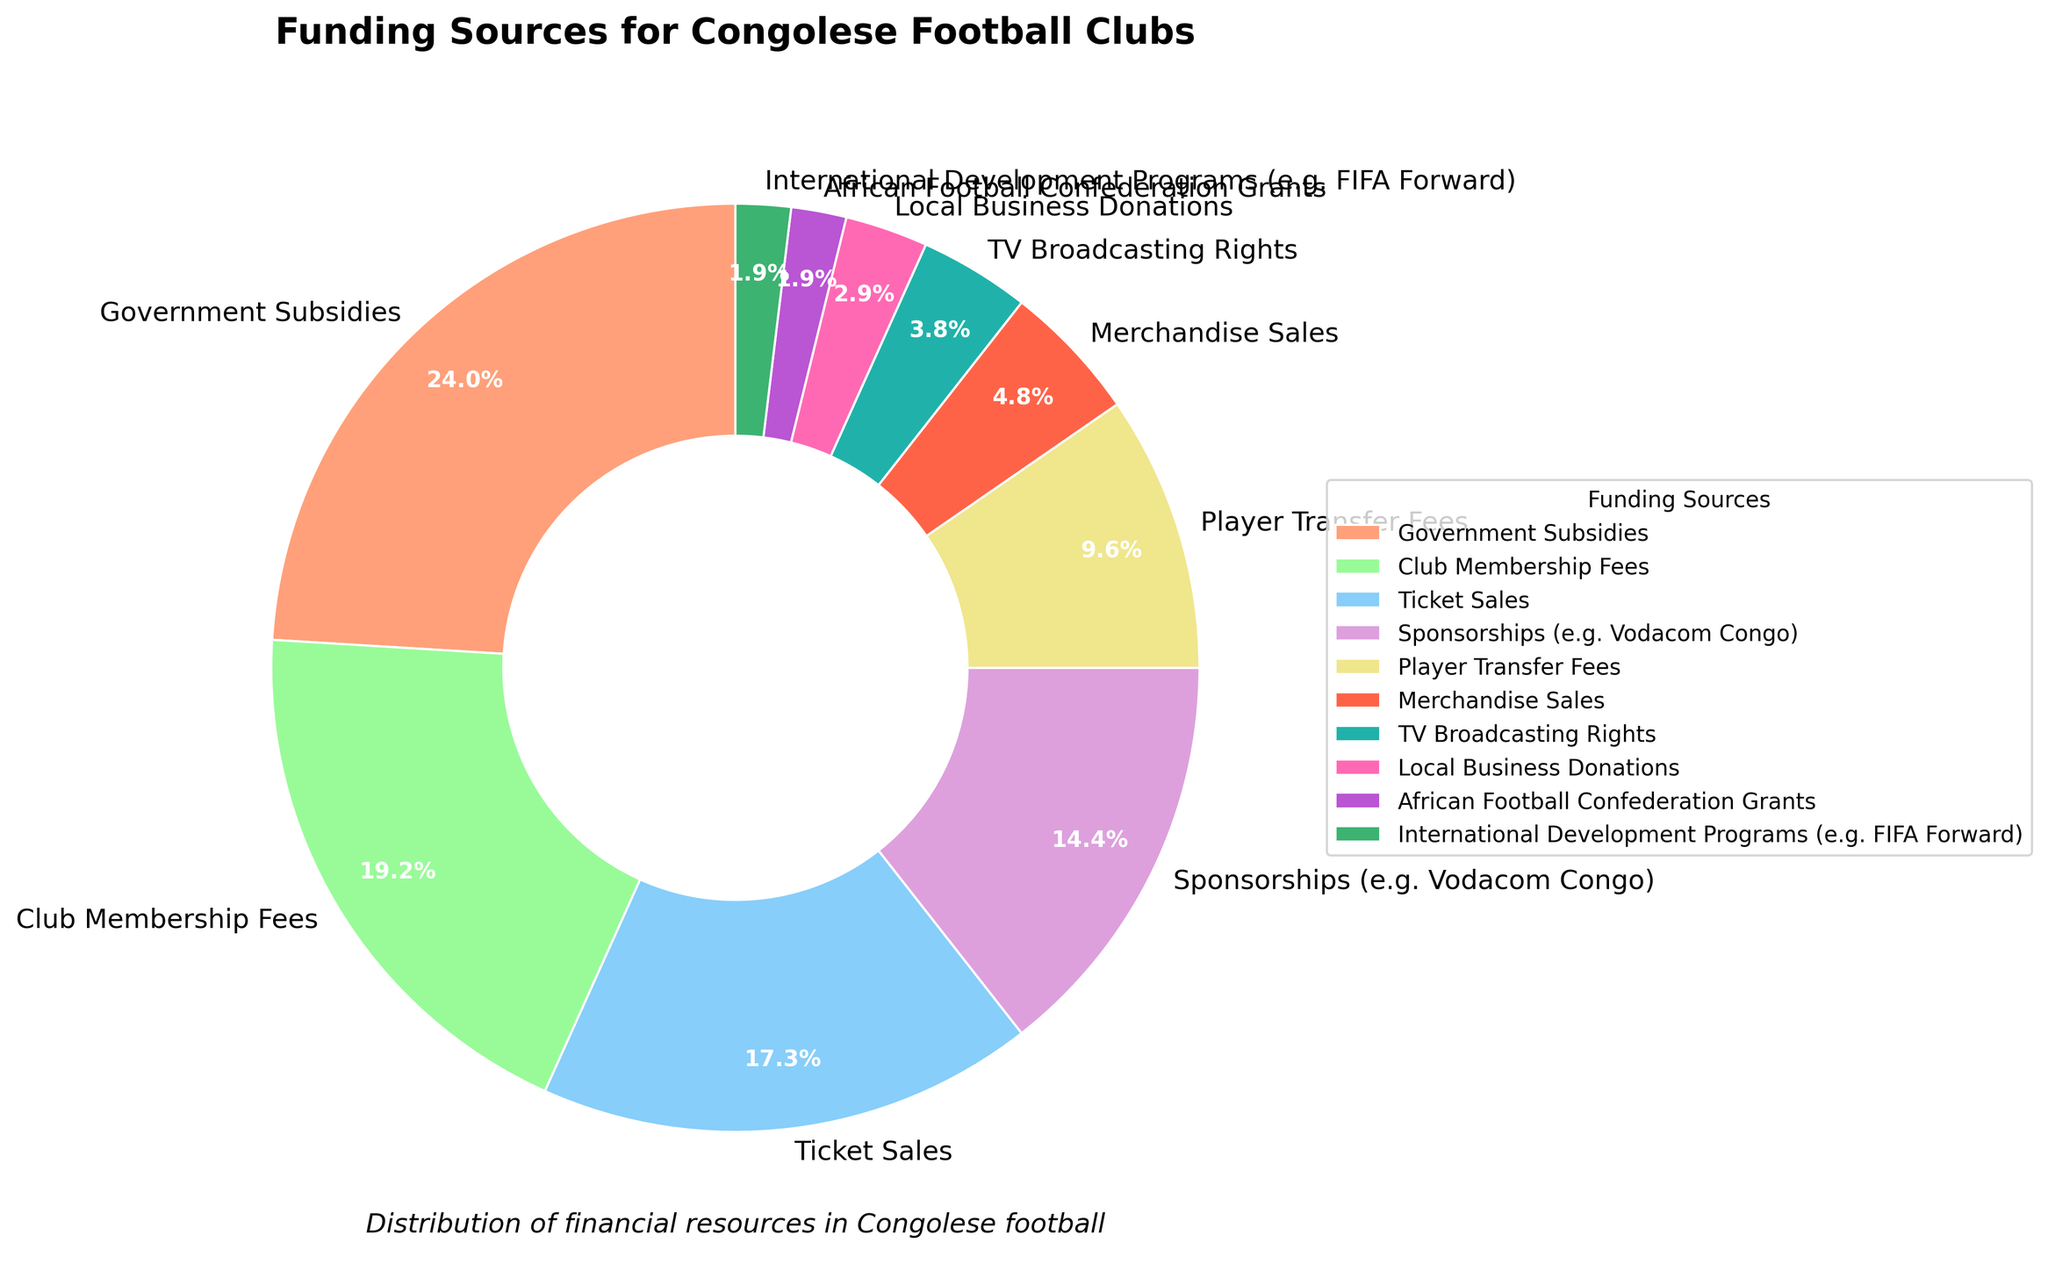What's the largest source of funding for Congolese football clubs? The figure shows that the largest segment represents Government Subsidies with 25%.
Answer: Government Subsidies Which source of funding is the least significant for Congolese football clubs? The smallest segment is represented by International Development Programs like FIFA Forward with 2%.
Answer: International Development Programs (e.g. FIFA Forward) How much greater is the percentage of Government Subsidies compared to Club Membership Fees? Government Subsidies account for 25%, and Club Membership Fees account for 20%. The difference is 25% - 20% = 5%.
Answer: 5% Which two funding sources combined make up the same percentage as Government Subsidies? Club Membership Fees and Ticket Sales are 20% and 18%; combined, this exceeds Government Subsidies. However, Club Membership Fees and Sponsorships (Vodacom Congo) combined are 20% + 15% = 35%. No single pair adds up to exactly 25%, but this pair closely resembles being notable.
Answer: No exact match What is the total percentage of funding derived from commercial activities (Sponsorships, Merchandise Sales, TV Broadcasting Rights)? Adding the percentages: Sponsorships (15%), Merchandise Sales (5%), TV Broadcasting Rights (4%) results in 15% + 5% + 4% = 24%.
Answer: 24% Which funding sources together constitute less than 10% of the total? The sources are Local Business Donations (3%), African Football Confederation Grants (2%), and International Development Programs (2%). Their combined percentage is 3% + 2% + 2% = 7%.
Answer: Local Business Donations, African Football Confederation Grants, International Development Programs How many sources of funding exceed 10% individually? The segments that exceed 10% are Government Subsidies (25%), Club Membership Fees (20%), Ticket Sales (18%), and Sponsorships (15%). This gives us four sources.
Answer: Four Which funding sources are represented by the yellow and pink segments? The yellow segment represents Club Membership Fees (20%), and the pink segment represents TV Broadcasting Rights (4%).
Answer: Club Membership Fees (yellow), TV Broadcasting Rights (pink) Are Merchandise Sales and Local Business Donations together more or less than Player Transfer Fees? Merchandise Sales and Local Business Donations combined are 5% + 3% = 8%, which is less than Player Transfer Fees at 10%.
Answer: Less 